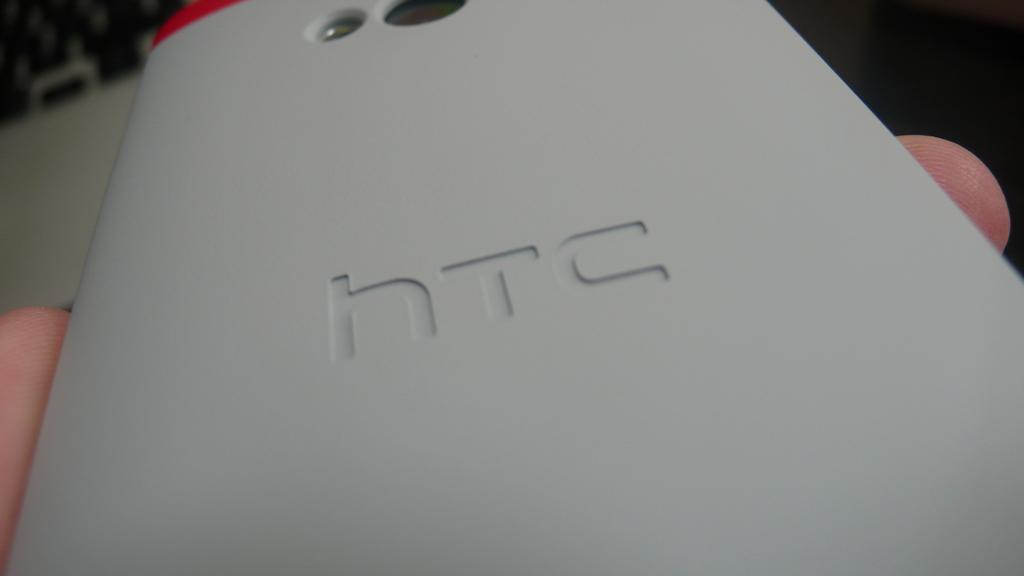<image>
Summarize the visual content of the image. A cell phone that has HTC written on the back. 